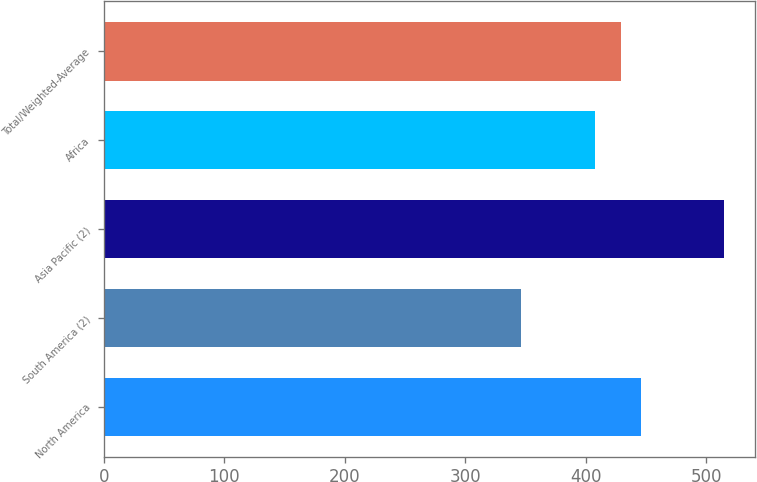Convert chart. <chart><loc_0><loc_0><loc_500><loc_500><bar_chart><fcel>North America<fcel>South America (2)<fcel>Asia Pacific (2)<fcel>Africa<fcel>Total/Weighted-Average<nl><fcel>445.9<fcel>346<fcel>515<fcel>408<fcel>429<nl></chart> 